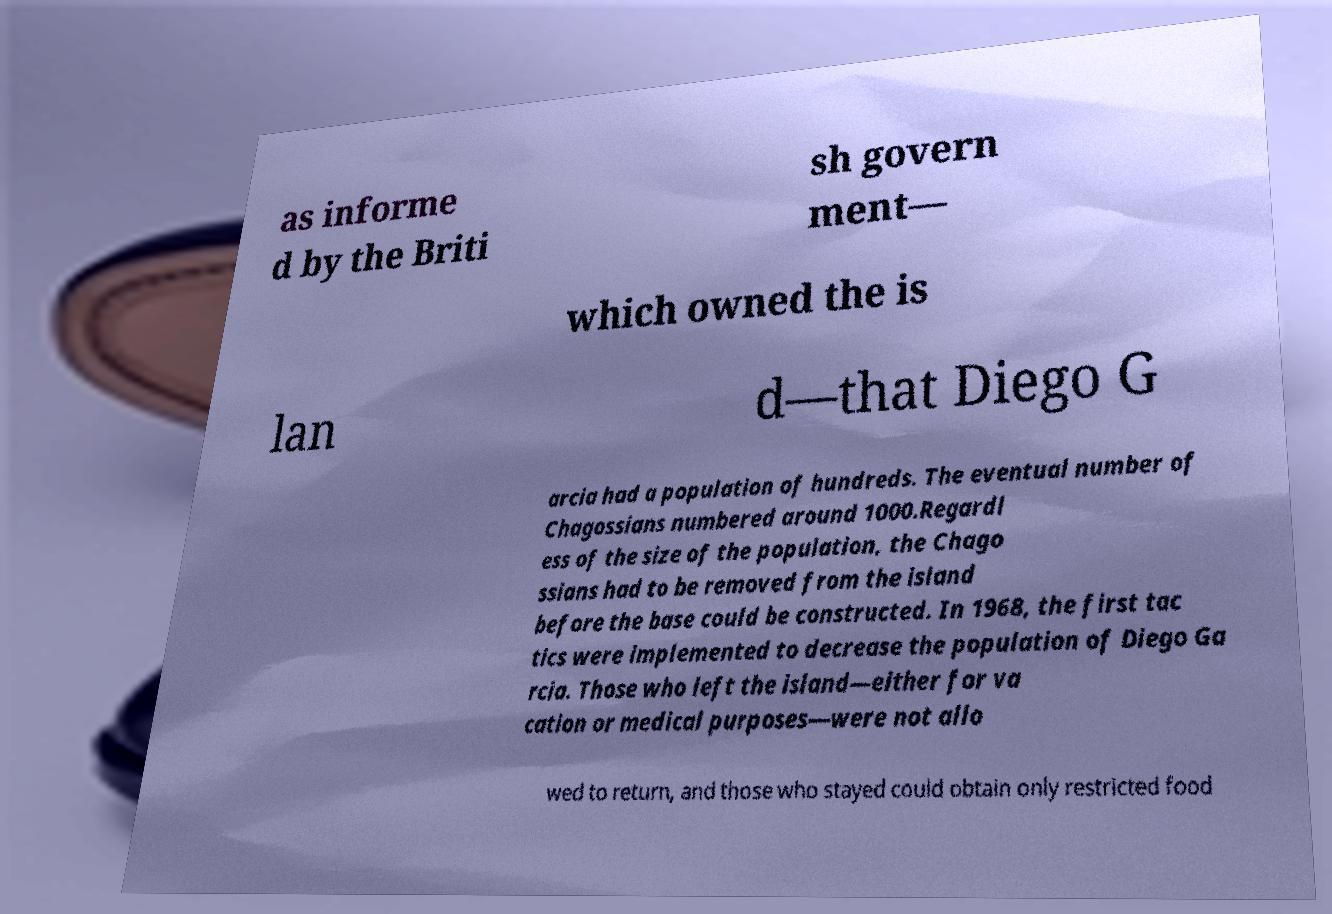Please read and relay the text visible in this image. What does it say? as informe d by the Briti sh govern ment— which owned the is lan d—that Diego G arcia had a population of hundreds. The eventual number of Chagossians numbered around 1000.Regardl ess of the size of the population, the Chago ssians had to be removed from the island before the base could be constructed. In 1968, the first tac tics were implemented to decrease the population of Diego Ga rcia. Those who left the island—either for va cation or medical purposes—were not allo wed to return, and those who stayed could obtain only restricted food 